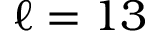Convert formula to latex. <formula><loc_0><loc_0><loc_500><loc_500>\ell = 1 3</formula> 